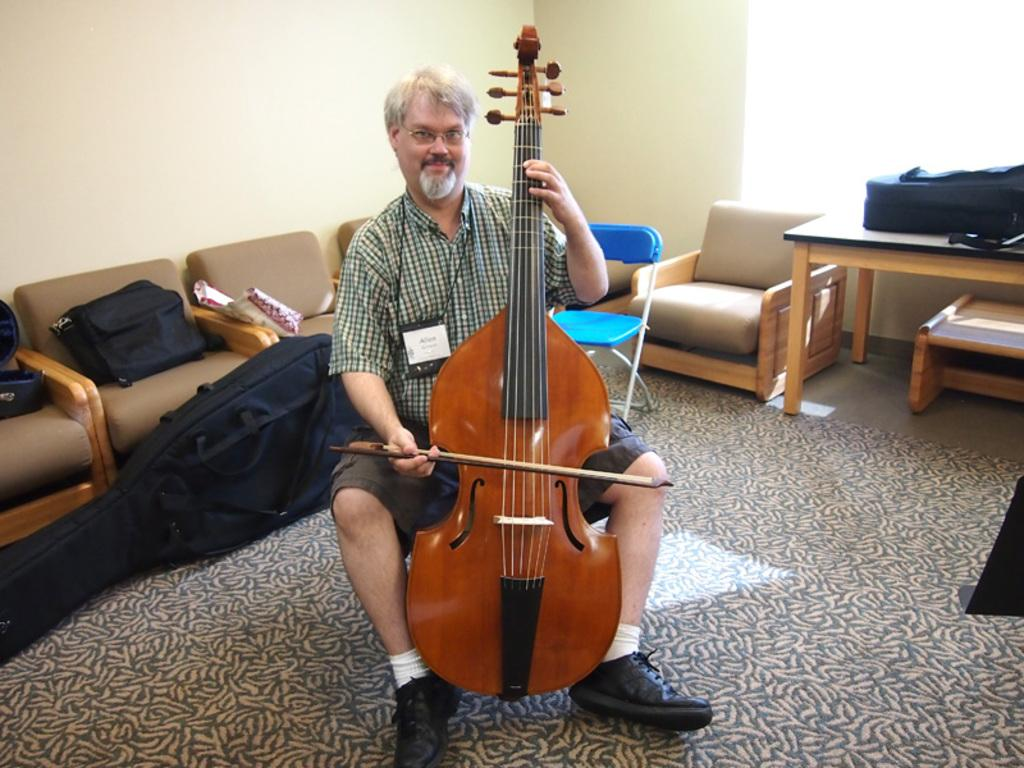What is the main subject of the image? The main subject of the image is a man. What is the man doing in the image? The man is sitting in the image. What is the man holding in the image? The man is holding a musical instrument in the image. What can be seen in the background of the image? In the background of the image, there are bags, a sofa set, a chair, a wall, and a table. What type of basket is being used to promote peace in the image? There is no basket or any reference to promoting peace in the image. 